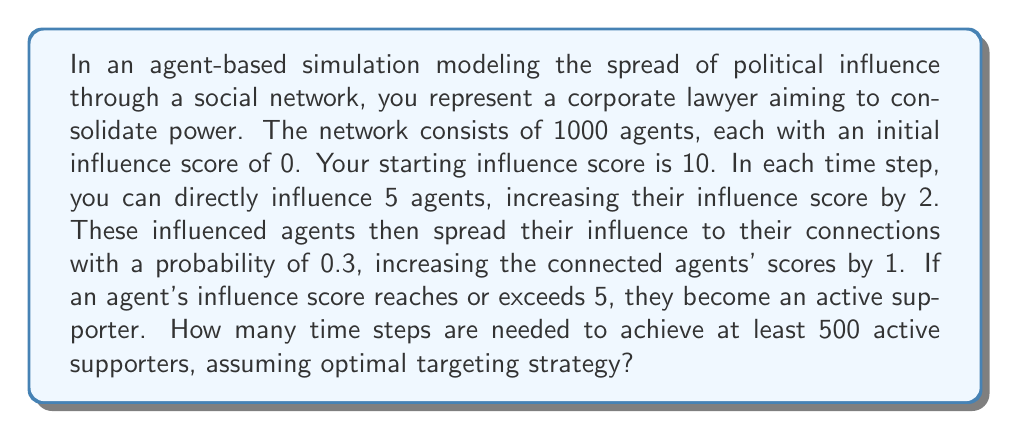Give your solution to this math problem. Let's approach this step-by-step:

1) In each time step, you directly influence 5 agents:
   $5 \times 2 = 10$ total influence points distributed per step

2) These 5 agents each have a 0.3 probability of influencing their connections:
   Expected secondary influence: $5 \times 0.3 = 1.5$ agents

3) Secondary influence increases scores by 1:
   $1.5 \times 1 = 1.5$ additional influence points per step

4) Total expected influence points per step:
   $10 + 1.5 = 11.5$ points

5) To become an active supporter, an agent needs 5 influence points.
   $500 \times 5 = 2500$ total influence points needed for 500 supporters

6) Time steps needed:
   $$\text{Time steps} = \frac{\text{Total influence needed}}{\text{Influence per step}}$$
   $$\text{Time steps} = \frac{2500}{11.5} \approx 217.39$$

7) Since we can only have whole time steps, we round up to 218.

This calculation assumes optimal targeting (no overlapping influence) and uses expected values for probabilistic events. In a real simulation, results may vary due to the stochastic nature of the process.
Answer: 218 time steps 